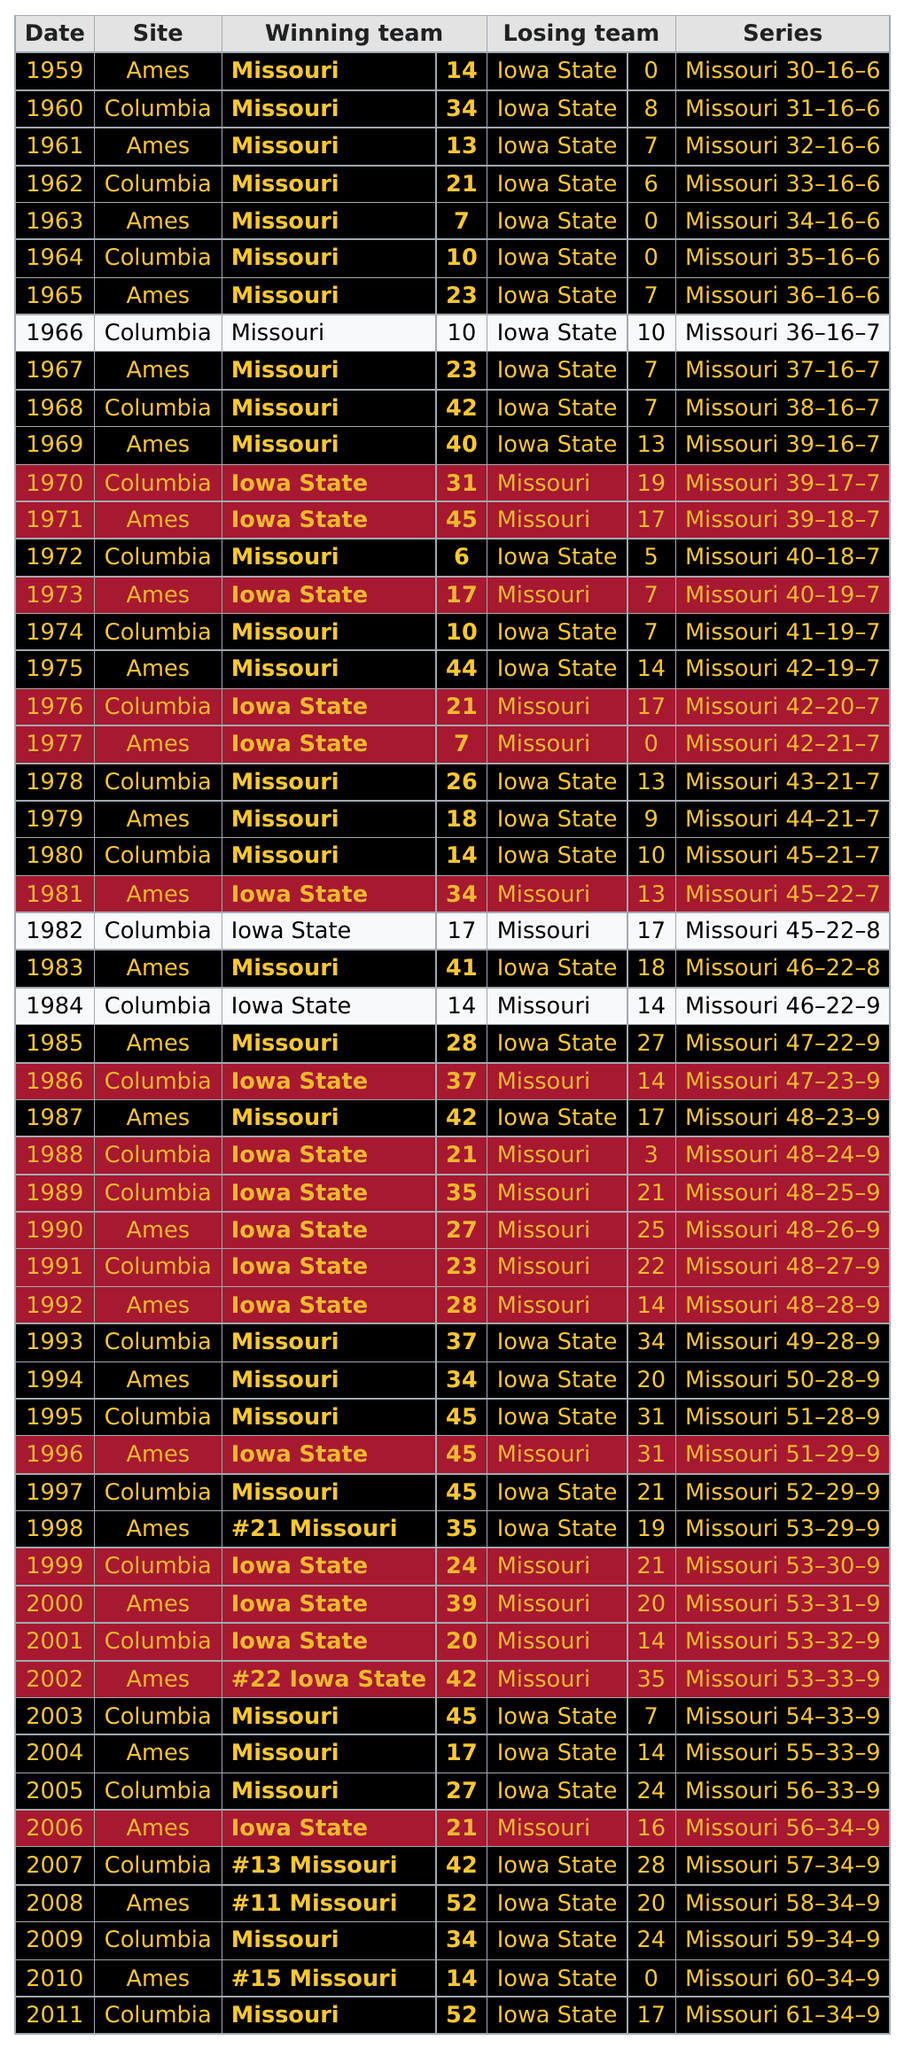Outline some significant characteristics in this image. Iowa State won the championship four times in the 21st century. The score was higher for the winning team in 1960 than in 1959. The only site where both teams had ever tied the game was Columbia. In the year 2000, the state of Missouri won the football game a total of 8 times. In 1965, it was Missouri who scored the most points. 